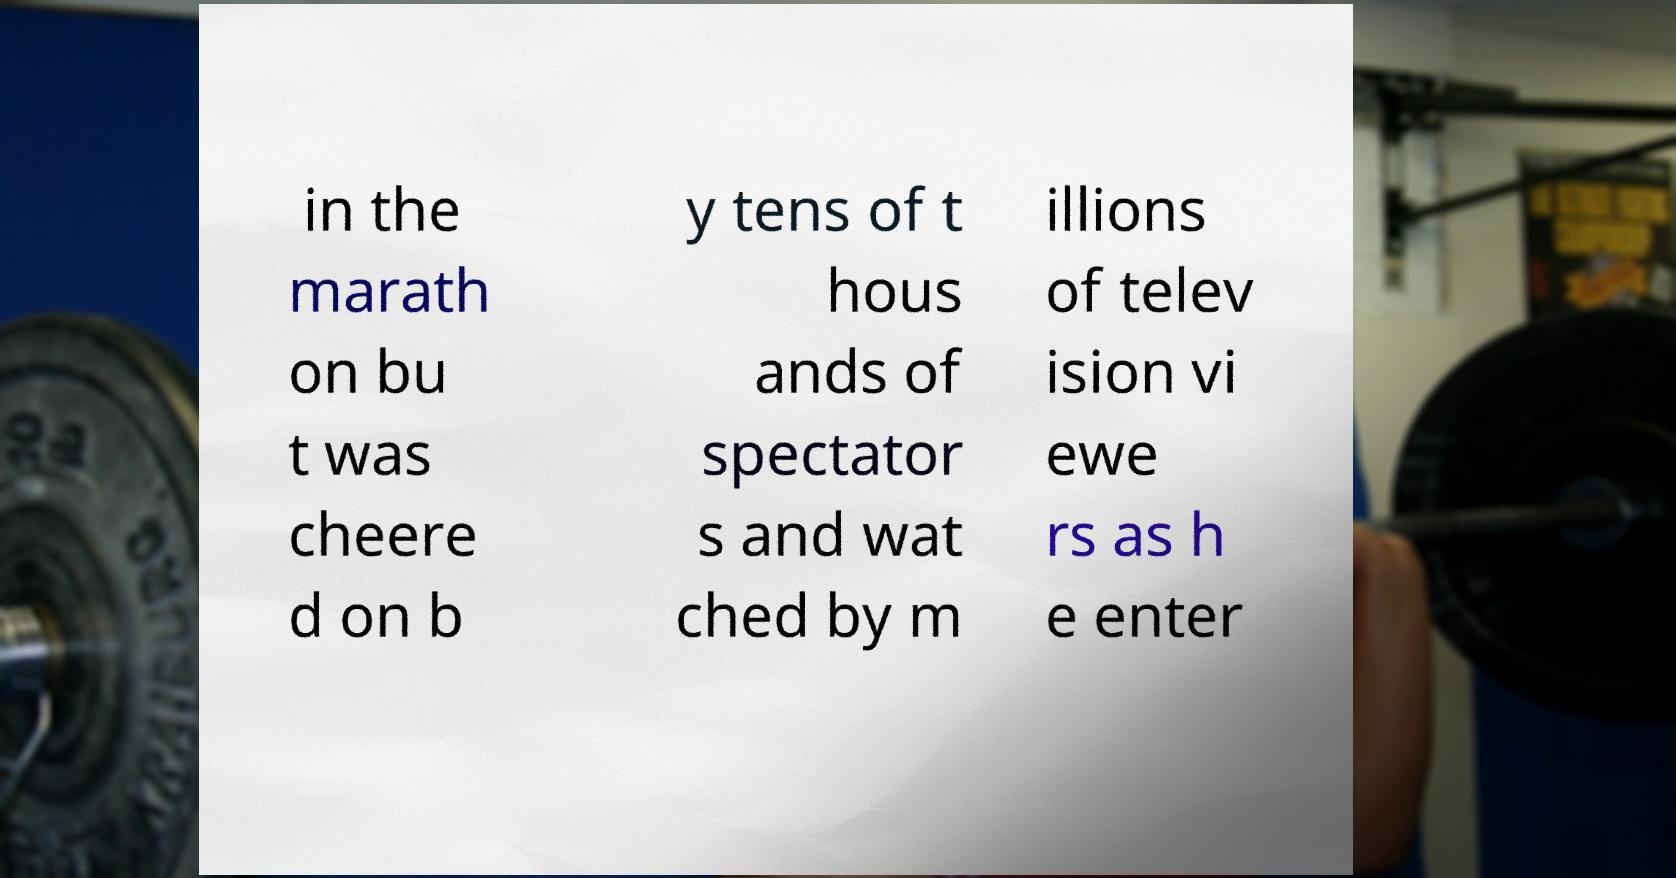There's text embedded in this image that I need extracted. Can you transcribe it verbatim? in the marath on bu t was cheere d on b y tens of t hous ands of spectator s and wat ched by m illions of telev ision vi ewe rs as h e enter 